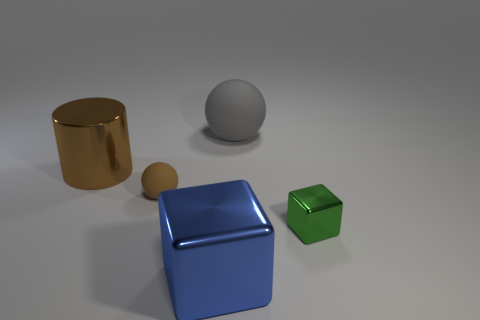Do the gray thing and the matte thing that is to the left of the large sphere have the same size?
Offer a terse response. No. What number of objects are either big things that are right of the metal cylinder or blocks in front of the green metal cube?
Give a very brief answer. 2. There is a green thing that is the same size as the brown rubber ball; what shape is it?
Your answer should be compact. Cube. What is the shape of the shiny object in front of the block that is behind the block to the left of the big gray ball?
Your response must be concise. Cube. Is the number of large objects that are in front of the tiny brown rubber object the same as the number of large red spheres?
Provide a succinct answer. No. Is the size of the gray thing the same as the blue shiny object?
Offer a very short reply. Yes. What number of rubber things are yellow cylinders or gray spheres?
Make the answer very short. 1. There is a brown thing that is the same size as the blue object; what is it made of?
Your answer should be very brief. Metal. What number of other things are there of the same material as the gray object
Provide a short and direct response. 1. Are there fewer rubber spheres left of the large block than small red objects?
Provide a succinct answer. No. 